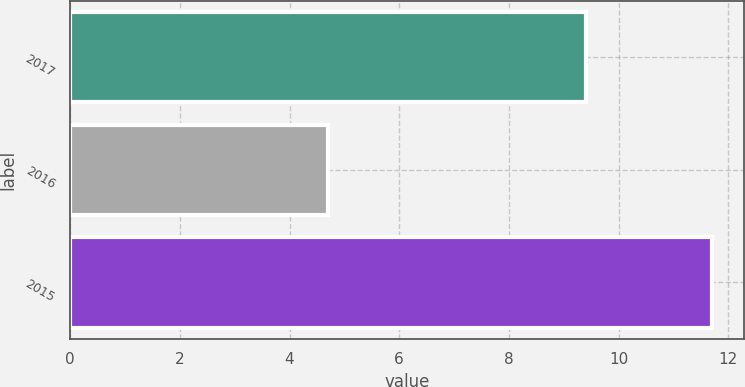<chart> <loc_0><loc_0><loc_500><loc_500><bar_chart><fcel>2017<fcel>2016<fcel>2015<nl><fcel>9.4<fcel>4.7<fcel>11.7<nl></chart> 